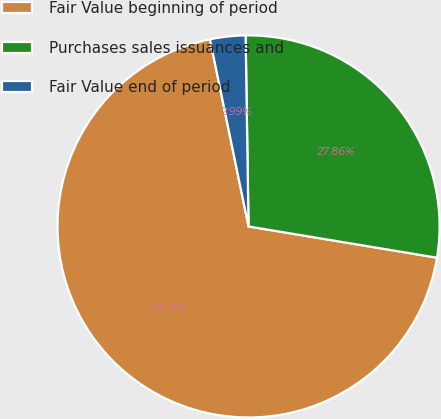Convert chart. <chart><loc_0><loc_0><loc_500><loc_500><pie_chart><fcel>Fair Value beginning of period<fcel>Purchases sales issuances and<fcel>Fair Value end of period<nl><fcel>69.15%<fcel>27.86%<fcel>2.99%<nl></chart> 